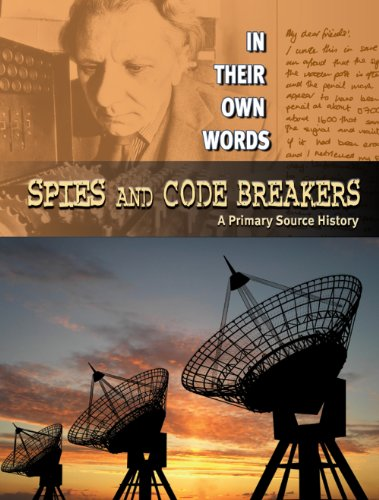What type of book is this? This is a children's book, specifically designed to educate young readers about historical events through primary sources and engaging narratives. 